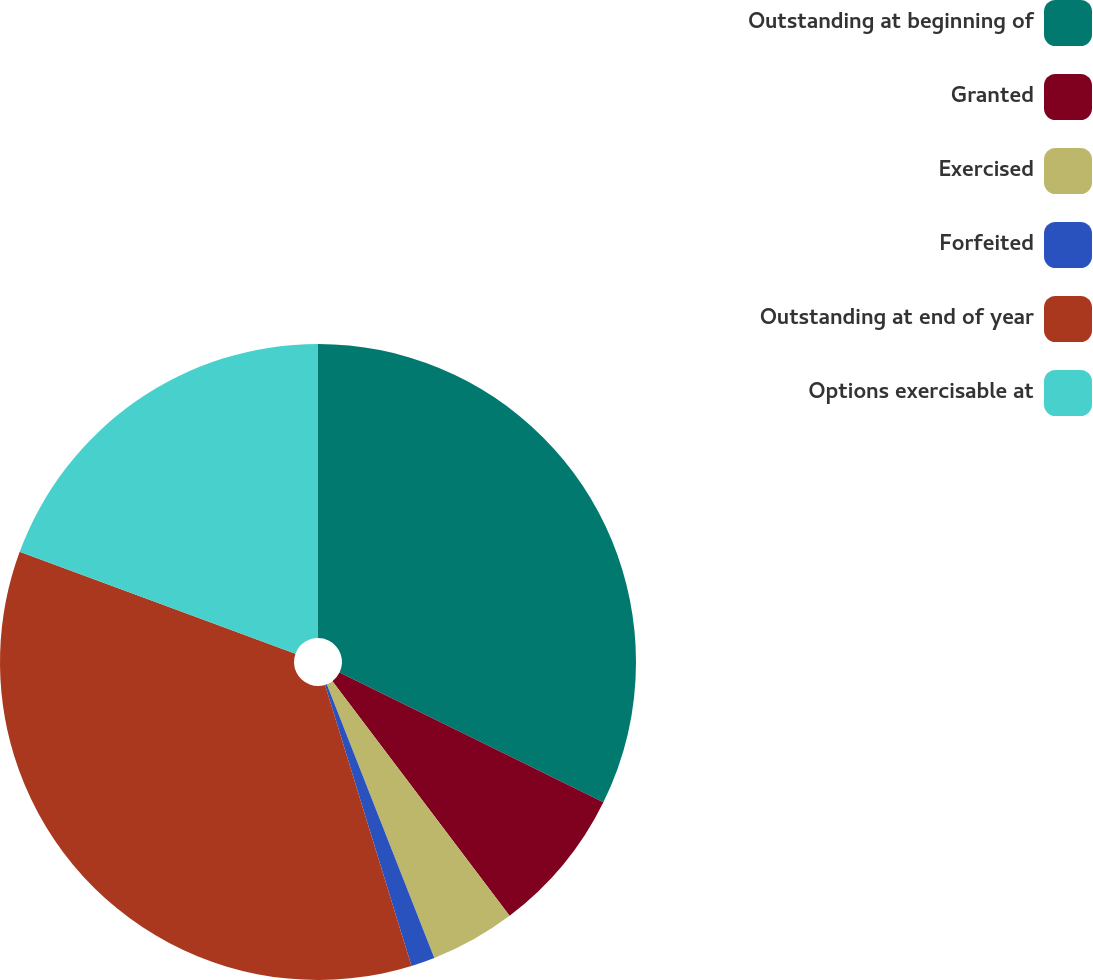<chart> <loc_0><loc_0><loc_500><loc_500><pie_chart><fcel>Outstanding at beginning of<fcel>Granted<fcel>Exercised<fcel>Forfeited<fcel>Outstanding at end of year<fcel>Options exercisable at<nl><fcel>32.27%<fcel>7.44%<fcel>4.33%<fcel>1.21%<fcel>35.38%<fcel>19.37%<nl></chart> 